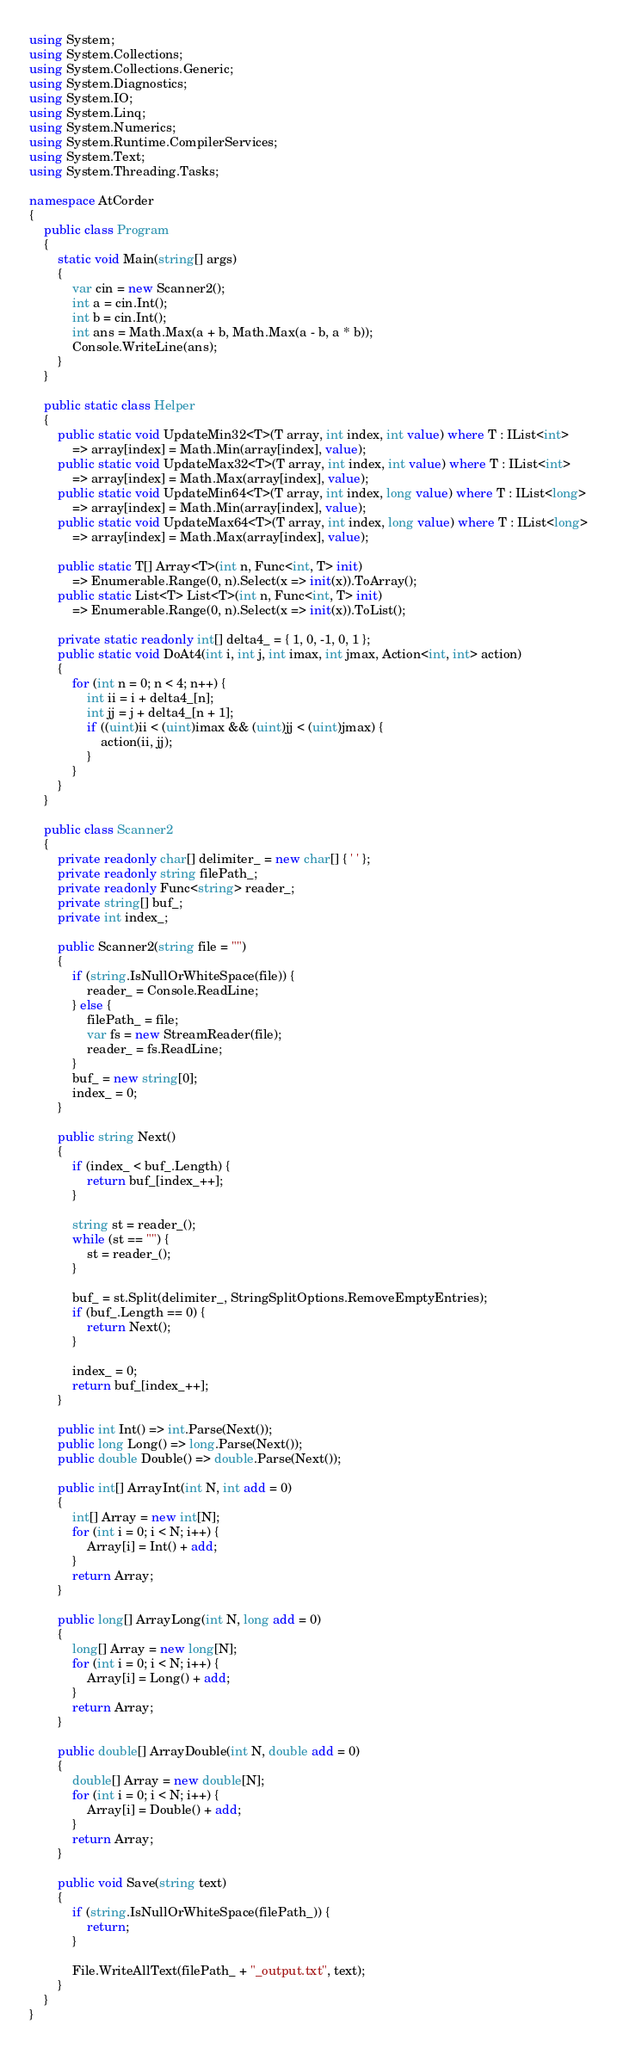<code> <loc_0><loc_0><loc_500><loc_500><_C#_>using System;
using System.Collections;
using System.Collections.Generic;
using System.Diagnostics;
using System.IO;
using System.Linq;
using System.Numerics;
using System.Runtime.CompilerServices;
using System.Text;
using System.Threading.Tasks;

namespace AtCorder
{
	public class Program
	{
		static void Main(string[] args)
		{
			var cin = new Scanner2();
			int a = cin.Int();
			int b = cin.Int();
			int ans = Math.Max(a + b, Math.Max(a - b, a * b));
			Console.WriteLine(ans);
		}
	}

	public static class Helper
	{
		public static void UpdateMin32<T>(T array, int index, int value) where T : IList<int>
			=> array[index] = Math.Min(array[index], value);
		public static void UpdateMax32<T>(T array, int index, int value) where T : IList<int>
			=> array[index] = Math.Max(array[index], value);
		public static void UpdateMin64<T>(T array, int index, long value) where T : IList<long>
			=> array[index] = Math.Min(array[index], value);
		public static void UpdateMax64<T>(T array, int index, long value) where T : IList<long>
			=> array[index] = Math.Max(array[index], value);

		public static T[] Array<T>(int n, Func<int, T> init)
			=> Enumerable.Range(0, n).Select(x => init(x)).ToArray();
		public static List<T> List<T>(int n, Func<int, T> init)
			=> Enumerable.Range(0, n).Select(x => init(x)).ToList();

		private static readonly int[] delta4_ = { 1, 0, -1, 0, 1 };
		public static void DoAt4(int i, int j, int imax, int jmax, Action<int, int> action)
		{
			for (int n = 0; n < 4; n++) {
				int ii = i + delta4_[n];
				int jj = j + delta4_[n + 1];
				if ((uint)ii < (uint)imax && (uint)jj < (uint)jmax) {
					action(ii, jj);
				}
			}
		}
	}

	public class Scanner2
	{
		private readonly char[] delimiter_ = new char[] { ' ' };
		private readonly string filePath_;
		private readonly Func<string> reader_;
		private string[] buf_;
		private int index_;

		public Scanner2(string file = "")
		{
			if (string.IsNullOrWhiteSpace(file)) {
				reader_ = Console.ReadLine;
			} else {
				filePath_ = file;
				var fs = new StreamReader(file);
				reader_ = fs.ReadLine;
			}
			buf_ = new string[0];
			index_ = 0;
		}

		public string Next()
		{
			if (index_ < buf_.Length) {
				return buf_[index_++];
			}

			string st = reader_();
			while (st == "") {
				st = reader_();
			}

			buf_ = st.Split(delimiter_, StringSplitOptions.RemoveEmptyEntries);
			if (buf_.Length == 0) {
				return Next();
			}

			index_ = 0;
			return buf_[index_++];
		}

		public int Int() => int.Parse(Next());
		public long Long() => long.Parse(Next());
		public double Double() => double.Parse(Next());

		public int[] ArrayInt(int N, int add = 0)
		{
			int[] Array = new int[N];
			for (int i = 0; i < N; i++) {
				Array[i] = Int() + add;
			}
			return Array;
		}

		public long[] ArrayLong(int N, long add = 0)
		{
			long[] Array = new long[N];
			for (int i = 0; i < N; i++) {
				Array[i] = Long() + add;
			}
			return Array;
		}

		public double[] ArrayDouble(int N, double add = 0)
		{
			double[] Array = new double[N];
			for (int i = 0; i < N; i++) {
				Array[i] = Double() + add;
			}
			return Array;
		}

		public void Save(string text)
		{
			if (string.IsNullOrWhiteSpace(filePath_)) {
				return;
			}

			File.WriteAllText(filePath_ + "_output.txt", text);
		}
	}
}</code> 